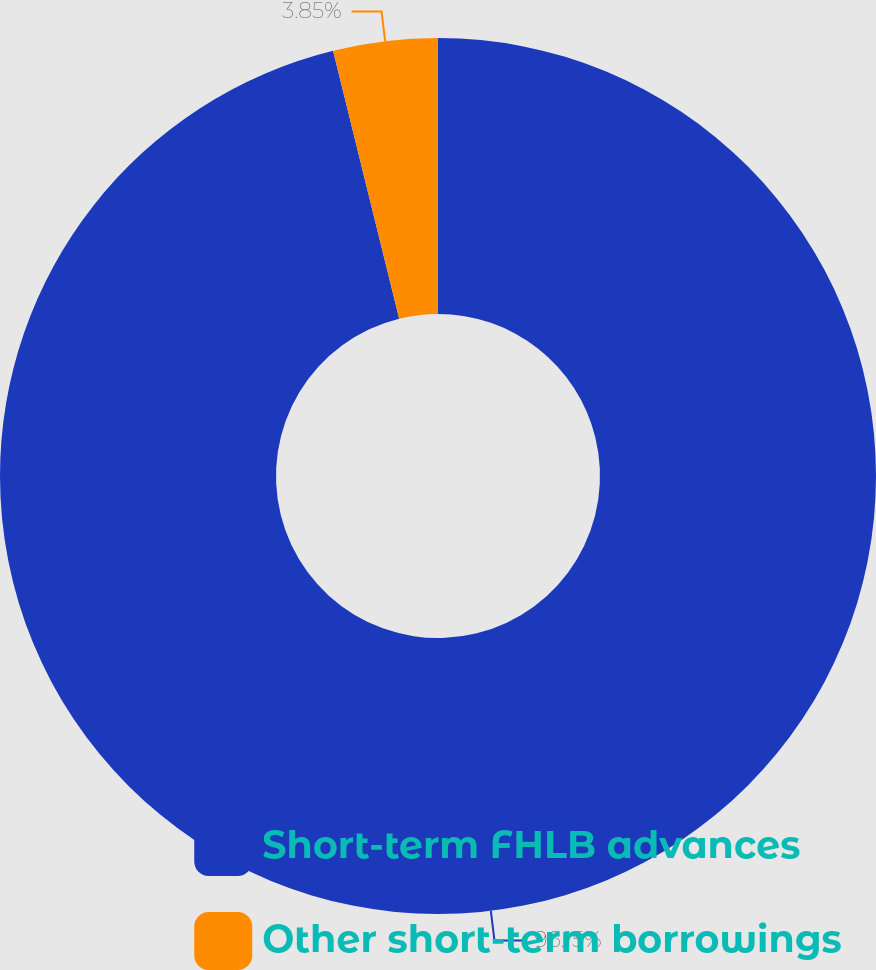Convert chart to OTSL. <chart><loc_0><loc_0><loc_500><loc_500><pie_chart><fcel>Short-term FHLB advances<fcel>Other short-term borrowings<nl><fcel>96.15%<fcel>3.85%<nl></chart> 